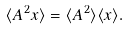<formula> <loc_0><loc_0><loc_500><loc_500>\langle { A ^ { 2 } x } \rangle = \langle { A ^ { 2 } } \rangle \langle { x } \rangle .</formula> 